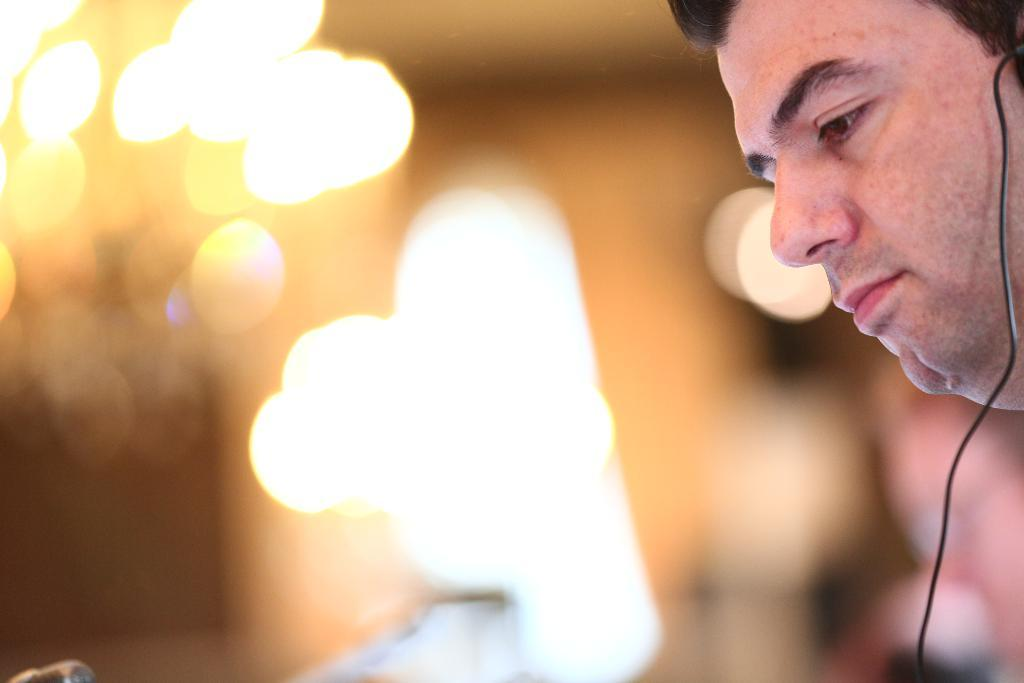Who is present on the right side of the image? There is a person on the right side of the image. What is the person wearing in the image? The person is wearing a headset in the image. Can you describe the background of the image? The background of the image is blurred. What can be seen in the image besides the person? There are lights visible in the image. What type of yoke is the person using to help with the meeting in the image? There is no yoke or meeting present in the image. 